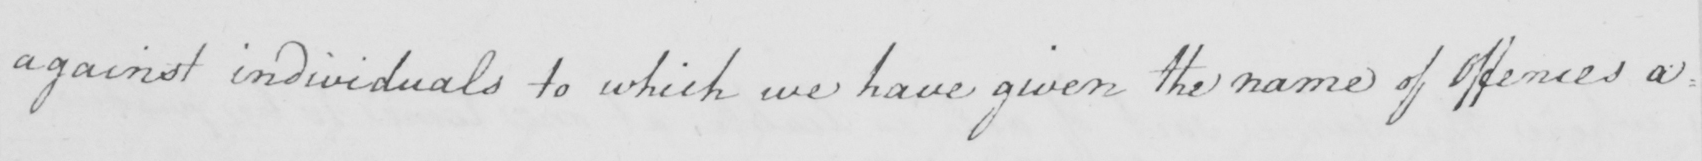Please provide the text content of this handwritten line. against individuals to which we have given the name of Offences a : 